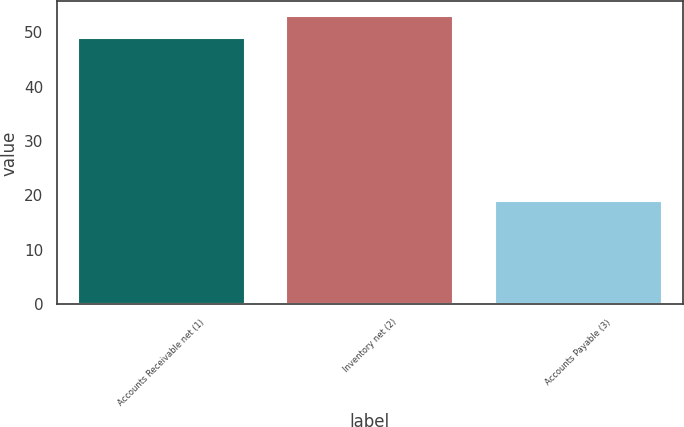Convert chart to OTSL. <chart><loc_0><loc_0><loc_500><loc_500><bar_chart><fcel>Accounts Receivable net (1)<fcel>Inventory net (2)<fcel>Accounts Payable (3)<nl><fcel>49<fcel>53<fcel>19<nl></chart> 